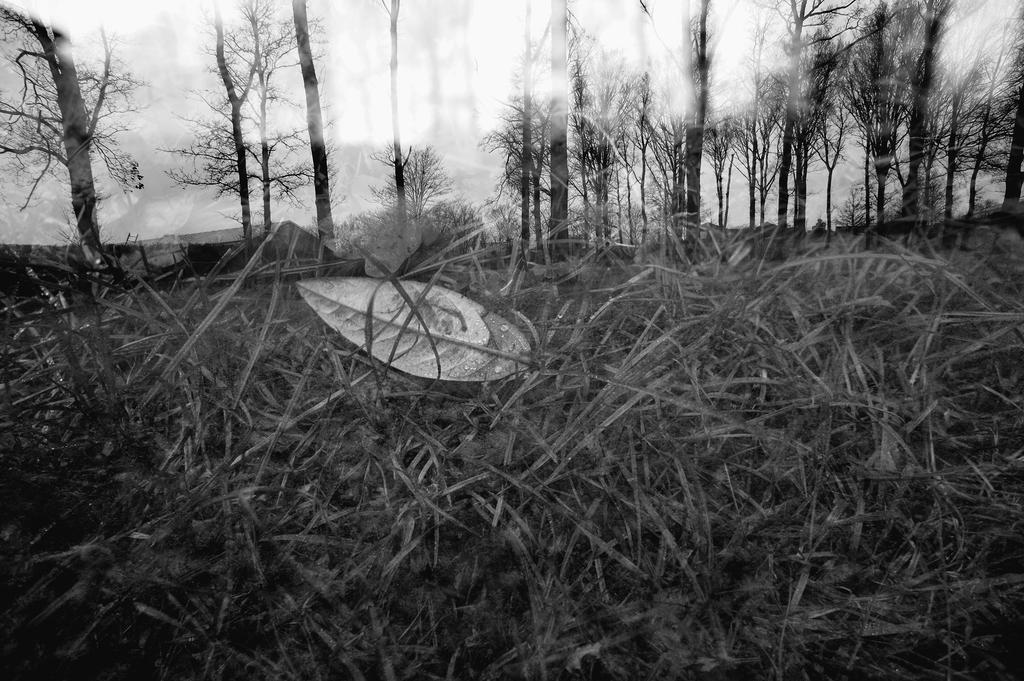What type of vegetation can be seen in the image? There are trees in the image. What is the ground covered with in the image? There is grass in the image. What else can be seen on the trees in the image? There are leaves in the image. What is visible in the background of the image? The sky is visible in the background of the image. What type of rhythm can be heard coming from the trees in the image? There is no sound or rhythm present in the image; it is a still image of trees, grass, and leaves. What type of bed can be seen in the image? There is no bed present in the image. 